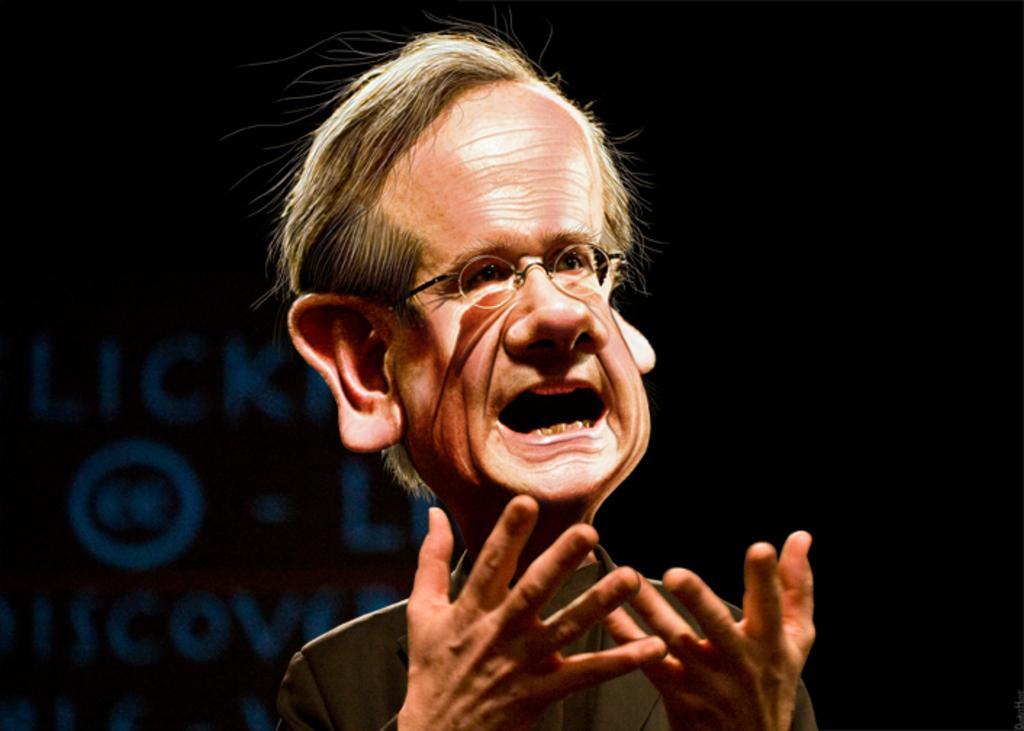In one or two sentences, can you explain what this image depicts? In this picture we can see a person's face, in the background there is some text, we can see a dark background. 